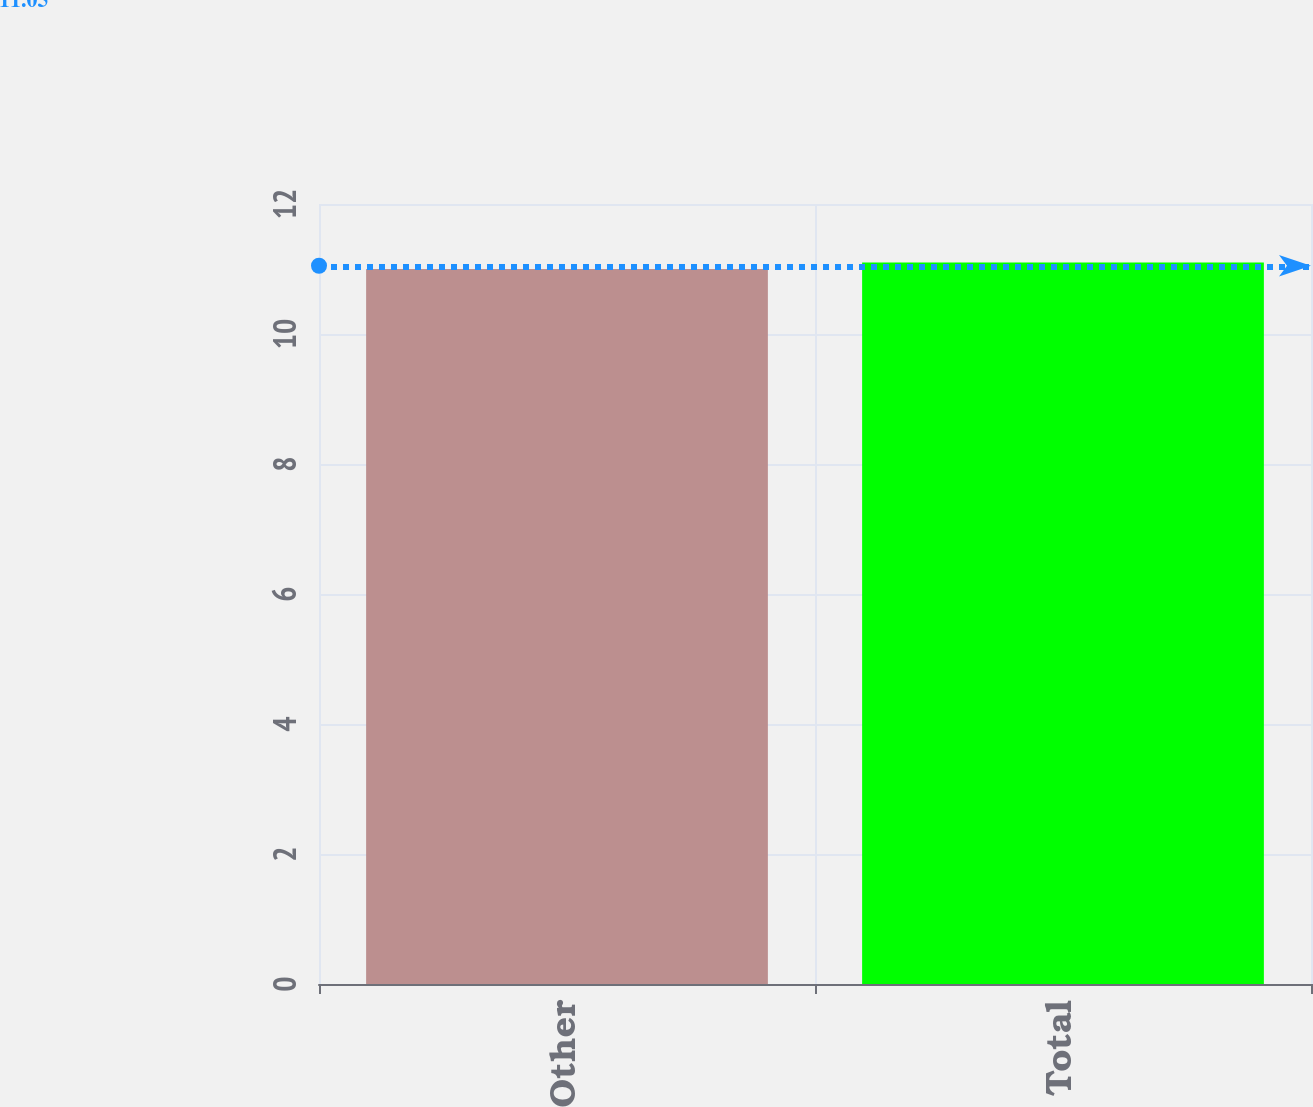Convert chart to OTSL. <chart><loc_0><loc_0><loc_500><loc_500><bar_chart><fcel>Other<fcel>Total<nl><fcel>11<fcel>11.1<nl></chart> 